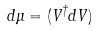Convert formula to latex. <formula><loc_0><loc_0><loc_500><loc_500>d \mu = ( V ^ { \dagger } d V )</formula> 